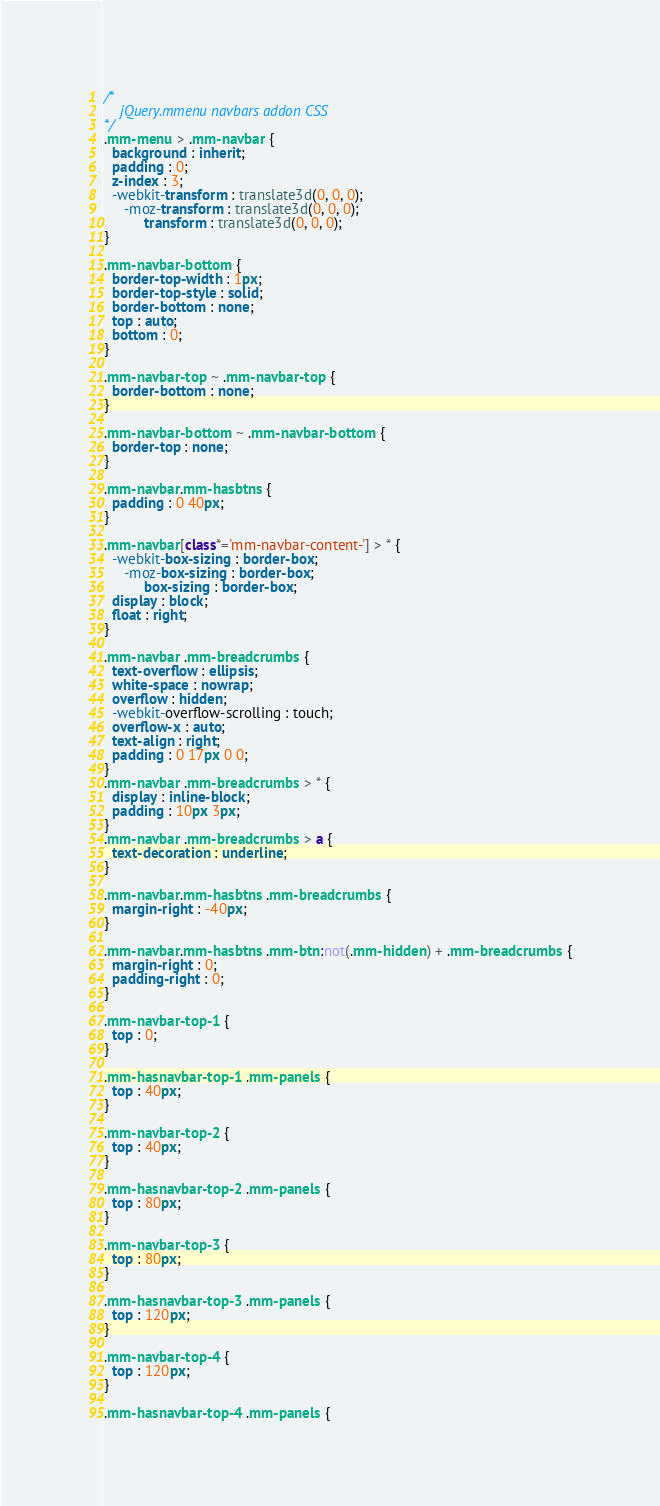<code> <loc_0><loc_0><loc_500><loc_500><_CSS_>/*
	jQuery.mmenu navbars addon CSS
*/
.mm-menu > .mm-navbar {
  background : inherit;
  padding : 0;
  z-index : 3;
  -webkit-transform : translate3d(0, 0, 0);
     -moz-transform : translate3d(0, 0, 0);
          transform : translate3d(0, 0, 0);
}

.mm-navbar-bottom {
  border-top-width : 1px;
  border-top-style : solid;
  border-bottom : none;
  top : auto;
  bottom : 0;
}

.mm-navbar-top ~ .mm-navbar-top {
  border-bottom : none;
}

.mm-navbar-bottom ~ .mm-navbar-bottom {
  border-top : none;
}

.mm-navbar.mm-hasbtns {
  padding : 0 40px;
}

.mm-navbar[class*='mm-navbar-content-'] > * {
  -webkit-box-sizing : border-box;
     -moz-box-sizing : border-box;
          box-sizing : border-box;
  display : block;
  float : right;
}

.mm-navbar .mm-breadcrumbs {
  text-overflow : ellipsis;
  white-space : nowrap;
  overflow : hidden;
  -webkit-overflow-scrolling : touch;
  overflow-x : auto;
  text-align : right;
  padding : 0 17px 0 0;
}
.mm-navbar .mm-breadcrumbs > * {
  display : inline-block;
  padding : 10px 3px;
}
.mm-navbar .mm-breadcrumbs > a {
  text-decoration : underline;
}

.mm-navbar.mm-hasbtns .mm-breadcrumbs {
  margin-right : -40px;
}

.mm-navbar.mm-hasbtns .mm-btn:not(.mm-hidden) + .mm-breadcrumbs {
  margin-right : 0;
  padding-right : 0;
}

.mm-navbar-top-1 {
  top : 0;
}

.mm-hasnavbar-top-1 .mm-panels {
  top : 40px;
}

.mm-navbar-top-2 {
  top : 40px;
}

.mm-hasnavbar-top-2 .mm-panels {
  top : 80px;
}

.mm-navbar-top-3 {
  top : 80px;
}

.mm-hasnavbar-top-3 .mm-panels {
  top : 120px;
}

.mm-navbar-top-4 {
  top : 120px;
}

.mm-hasnavbar-top-4 .mm-panels {</code> 